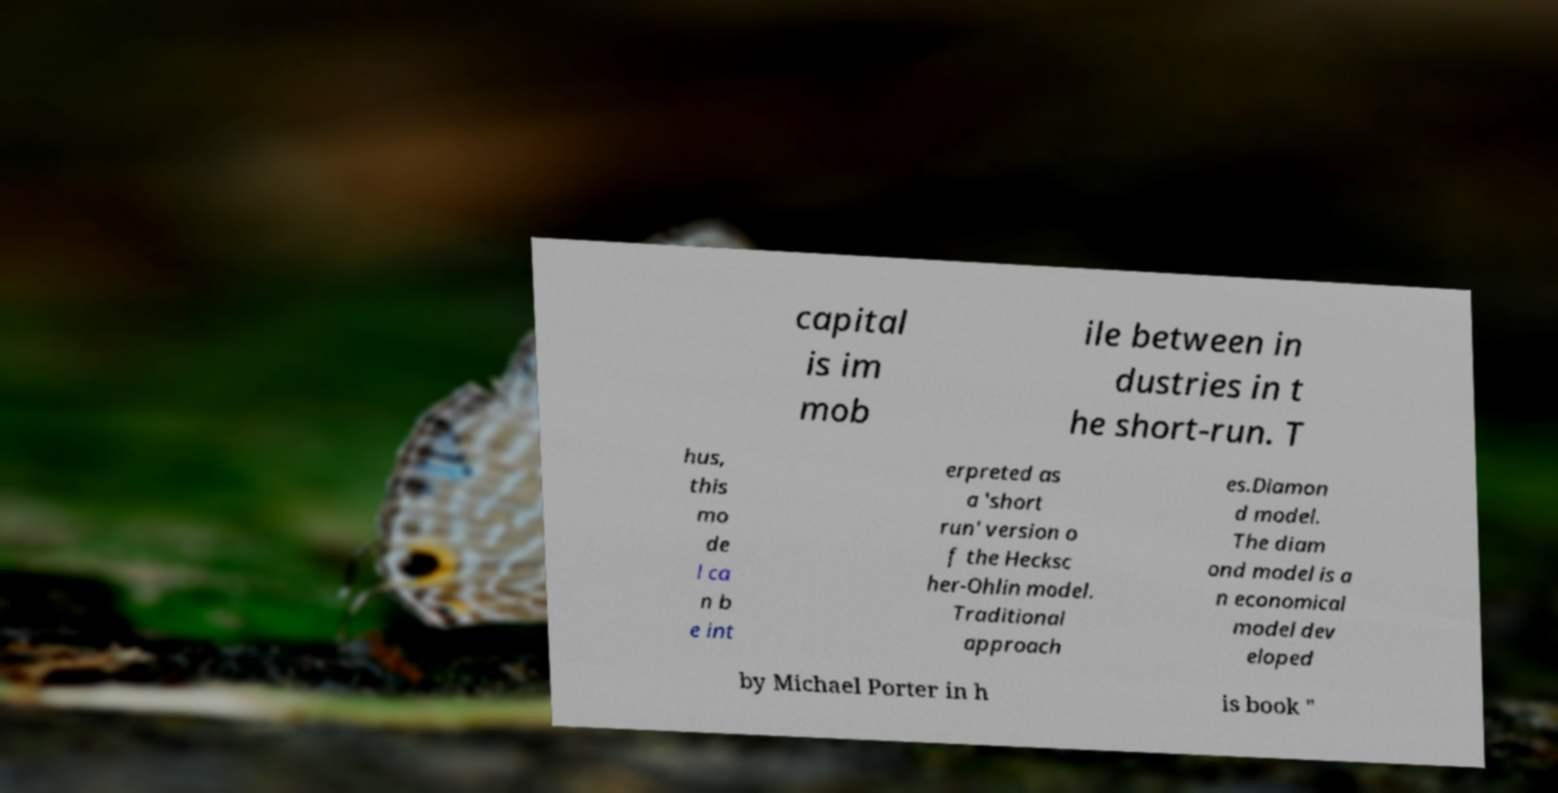Please identify and transcribe the text found in this image. capital is im mob ile between in dustries in t he short-run. T hus, this mo de l ca n b e int erpreted as a 'short run' version o f the Hecksc her-Ohlin model. Traditional approach es.Diamon d model. The diam ond model is a n economical model dev eloped by Michael Porter in h is book " 